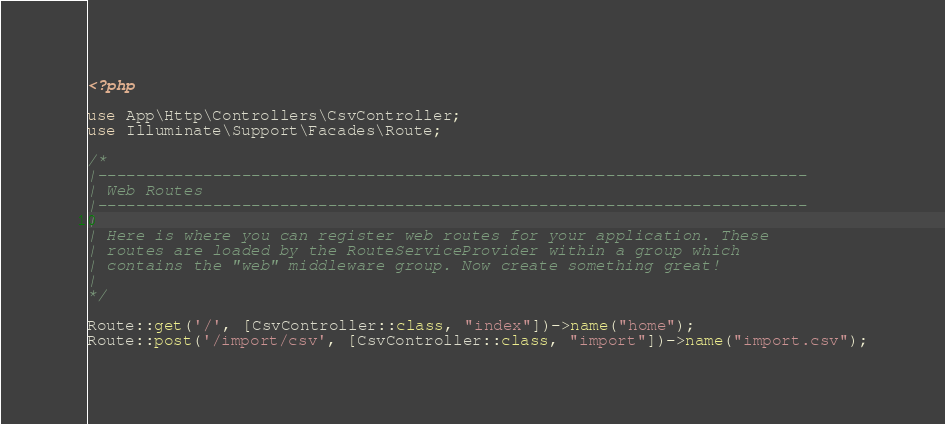<code> <loc_0><loc_0><loc_500><loc_500><_PHP_><?php

use App\Http\Controllers\CsvController;
use Illuminate\Support\Facades\Route;

/*
|--------------------------------------------------------------------------
| Web Routes
|--------------------------------------------------------------------------
|
| Here is where you can register web routes for your application. These
| routes are loaded by the RouteServiceProvider within a group which
| contains the "web" middleware group. Now create something great!
|
*/

Route::get('/', [CsvController::class, "index"])->name("home");
Route::post('/import/csv', [CsvController::class, "import"])->name("import.csv");
</code> 